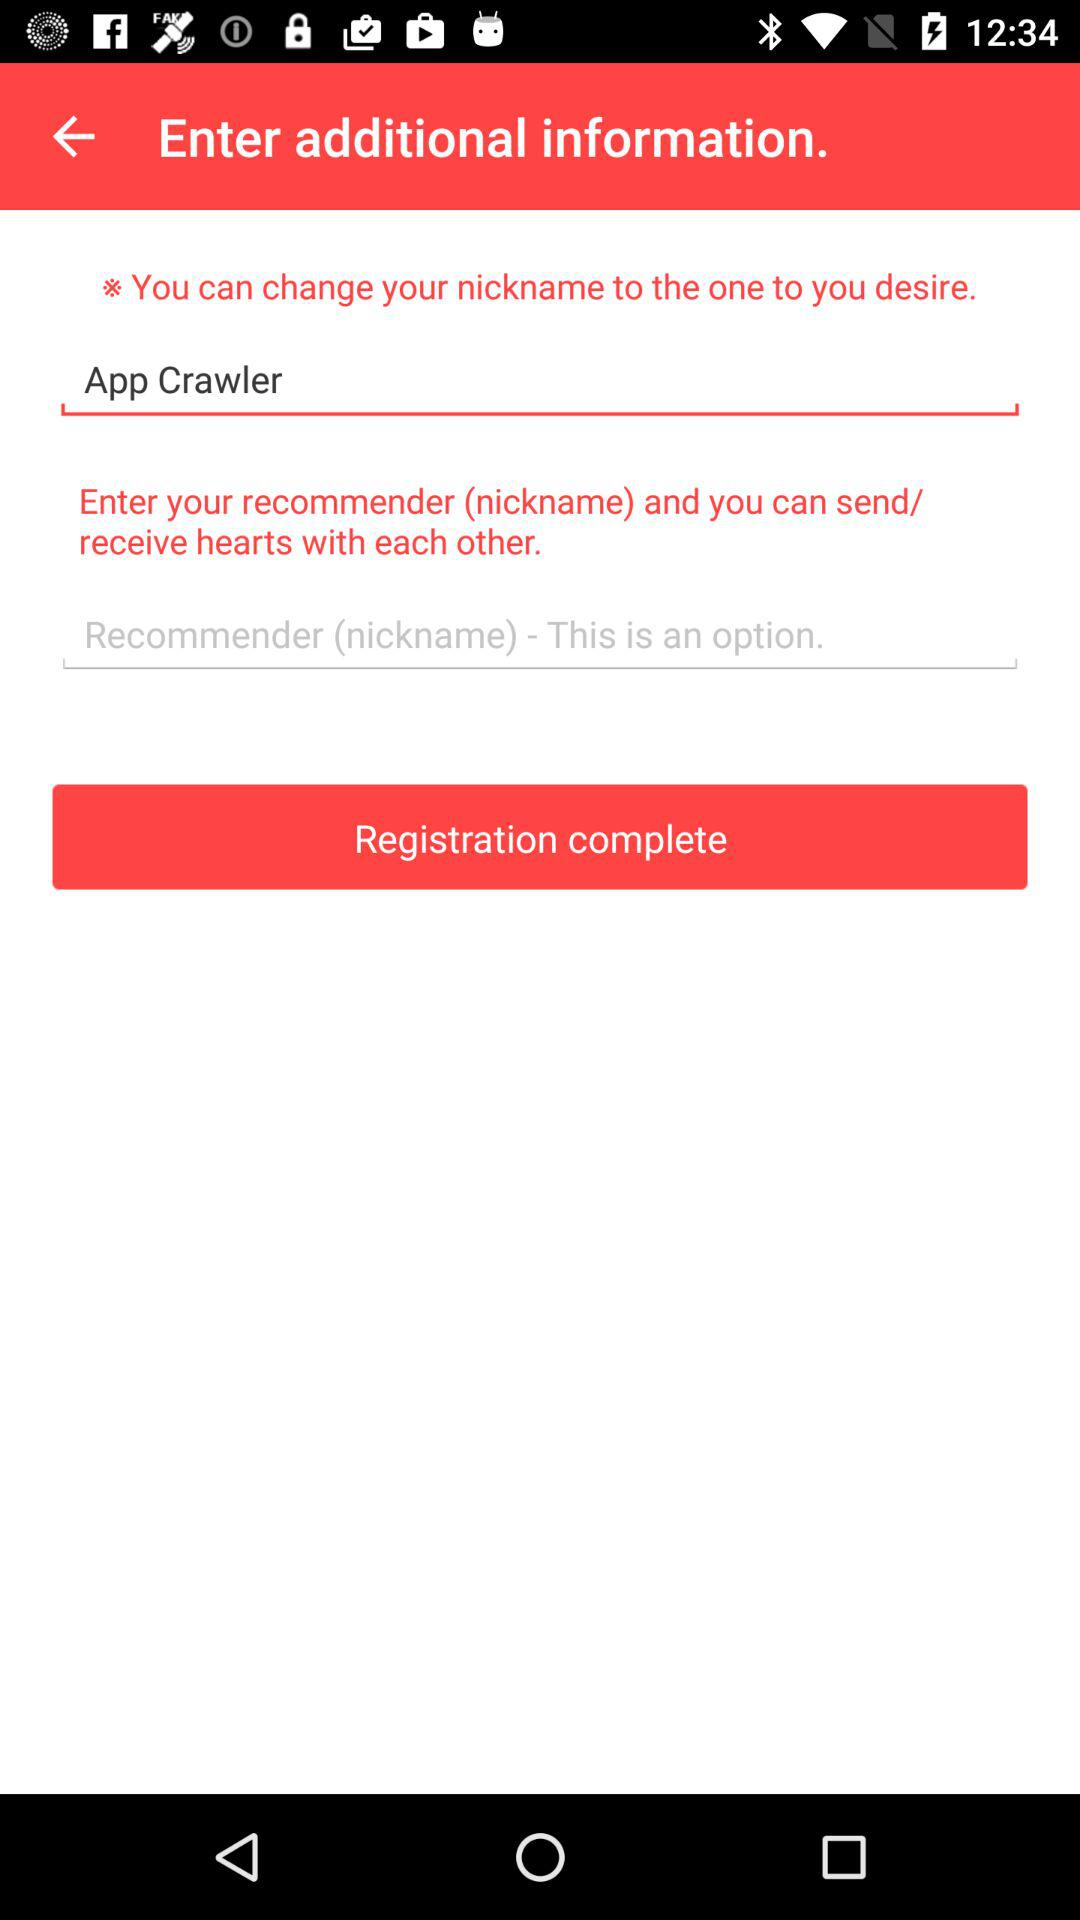How many text inputs are required to complete this form?
Answer the question using a single word or phrase. 2 